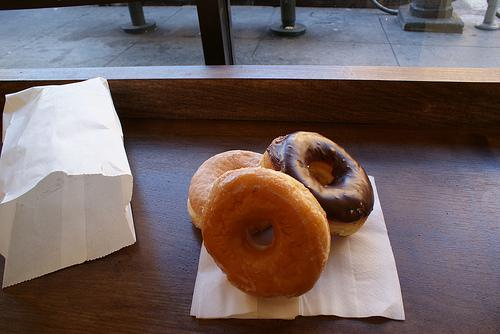Question: what is in the photo?
Choices:
A. Toys.
B. Ornaments.
C. Flowers.
D. Food.
Answer with the letter. Answer: D Question: who is in the photo?
Choices:
A. A large crowd.
B. A man.
C. Noone.
D. A grandmother.
Answer with the letter. Answer: C Question: what color is the background?
Choices:
A. Grey.
B. Brown.
C. Purple.
D. Green.
Answer with the letter. Answer: B Question: what are the food?
Choices:
A. Donuts.
B. Bagels.
C. Muffins.
D. Cupcakes.
Answer with the letter. Answer: A 